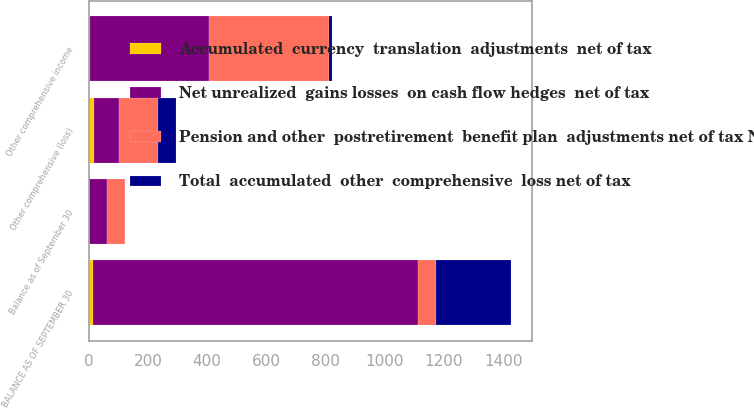Convert chart. <chart><loc_0><loc_0><loc_500><loc_500><stacked_bar_chart><ecel><fcel>Balance as of September 30<fcel>Other comprehensive income<fcel>BALANCE AS OF SEPTEMBER 30<fcel>Other comprehensive (loss)<nl><fcel>Net unrealized  gains losses  on cash flow hedges  net of tax<fcel>61.3<fcel>402.2<fcel>1097.1<fcel>85.6<nl><fcel>Total  accumulated  other  comprehensive  loss net of tax<fcel>0.5<fcel>8.3<fcel>252.4<fcel>61.3<nl><fcel>Accumulated  currency  translation  adjustments  net of tax<fcel>0.2<fcel>2.9<fcel>14.9<fcel>16.6<nl><fcel>Pension and other  postretirement  benefit plan  adjustments net of tax Note 11<fcel>61.3<fcel>407.6<fcel>61.3<fcel>130.3<nl></chart> 